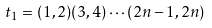<formula> <loc_0><loc_0><loc_500><loc_500>t _ { 1 } = ( 1 , 2 ) ( 3 , 4 ) \cdots ( 2 n - 1 , 2 n )</formula> 